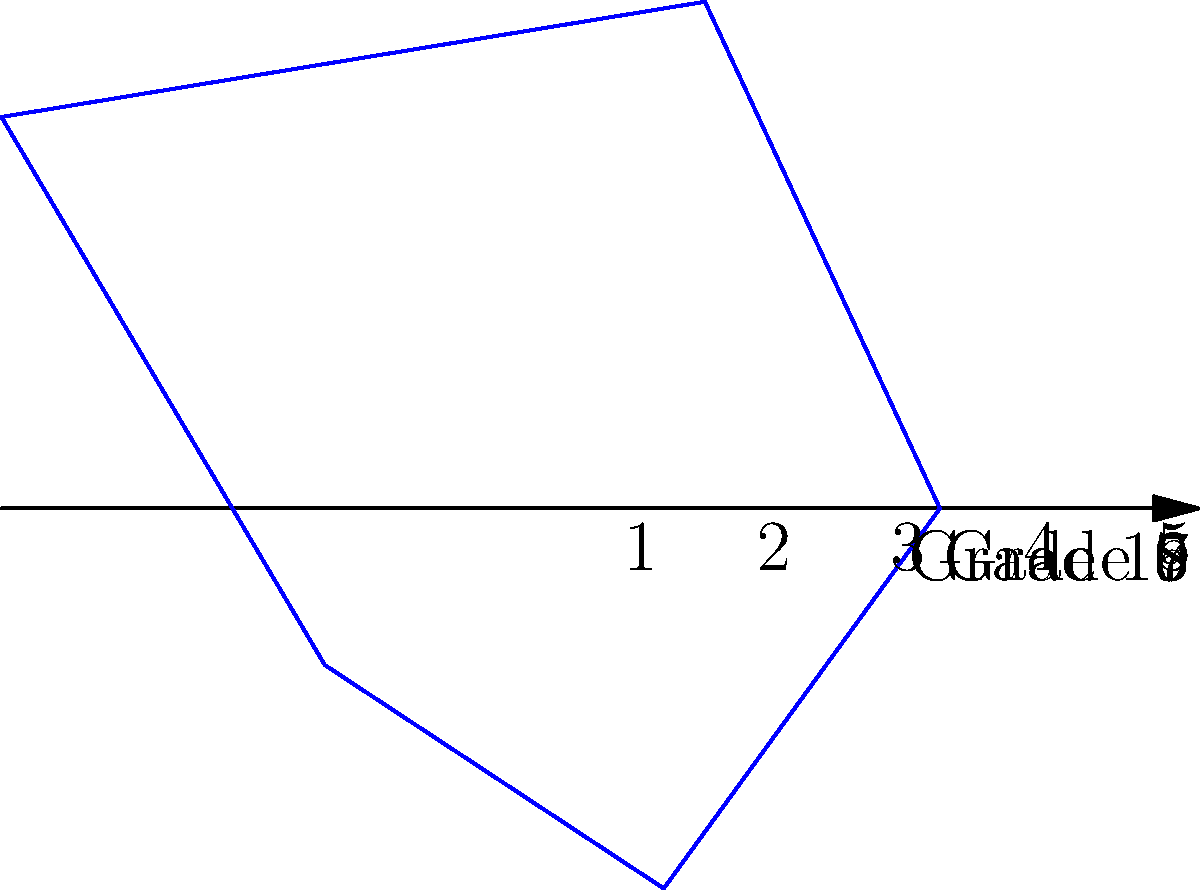The polar plot above represents the distribution of media literacy skills across different grade levels in your school. Each axis represents a grade level, and the distance from the center indicates the average media literacy score (on a scale of 1-5) for that grade. Which grade level shows the highest level of media literacy skills, and what implications does this have for your media literacy education program? To answer this question, we need to analyze the polar plot step-by-step:

1. Identify the grade levels:
   - The plot has 5 axes, representing Grades 6, 7, 8, 9, and 10.

2. Interpret the scores:
   - The distance from the center represents the average media literacy score.
   - The scale ranges from 1 (lowest) to 5 (highest).

3. Compare the scores:
   - Grade 6: $r \approx 3$
   - Grade 7: $r \approx 4$
   - Grade 8: $r = 5$
   - Grade 9: $r = 2$
   - Grade 10: $r = 3$

4. Identify the highest score:
   - Grade 8 has the highest score of 5.

5. Implications for the media literacy education program:
   - The program seems most effective for Grade 8 students.
   - There's a significant drop in scores for Grades 9 and 10, indicating a need for reinforcement.
   - The program might need adjustments for younger (Grade 6) and older (Grades 9-10) students.
   - Consider investigating the successful practices used in Grade 8 and adapting them for other grades.
   - Develop targeted interventions for Grades 9 and 10 to address the decline in media literacy skills.
Answer: Grade 8; reinforcement needed for Grades 9-10, investigate Grade 8 practices. 